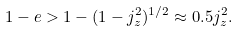<formula> <loc_0><loc_0><loc_500><loc_500>1 - e > 1 - ( 1 - j _ { z } ^ { 2 } ) ^ { 1 / 2 } \approx 0 . 5 j _ { z } ^ { 2 } .</formula> 